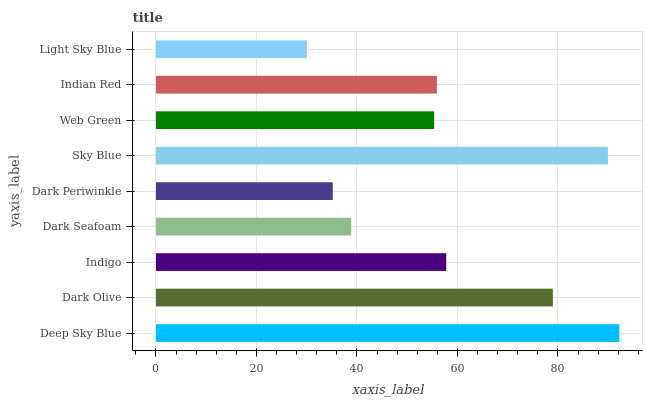Is Light Sky Blue the minimum?
Answer yes or no. Yes. Is Deep Sky Blue the maximum?
Answer yes or no. Yes. Is Dark Olive the minimum?
Answer yes or no. No. Is Dark Olive the maximum?
Answer yes or no. No. Is Deep Sky Blue greater than Dark Olive?
Answer yes or no. Yes. Is Dark Olive less than Deep Sky Blue?
Answer yes or no. Yes. Is Dark Olive greater than Deep Sky Blue?
Answer yes or no. No. Is Deep Sky Blue less than Dark Olive?
Answer yes or no. No. Is Indian Red the high median?
Answer yes or no. Yes. Is Indian Red the low median?
Answer yes or no. Yes. Is Web Green the high median?
Answer yes or no. No. Is Indigo the low median?
Answer yes or no. No. 